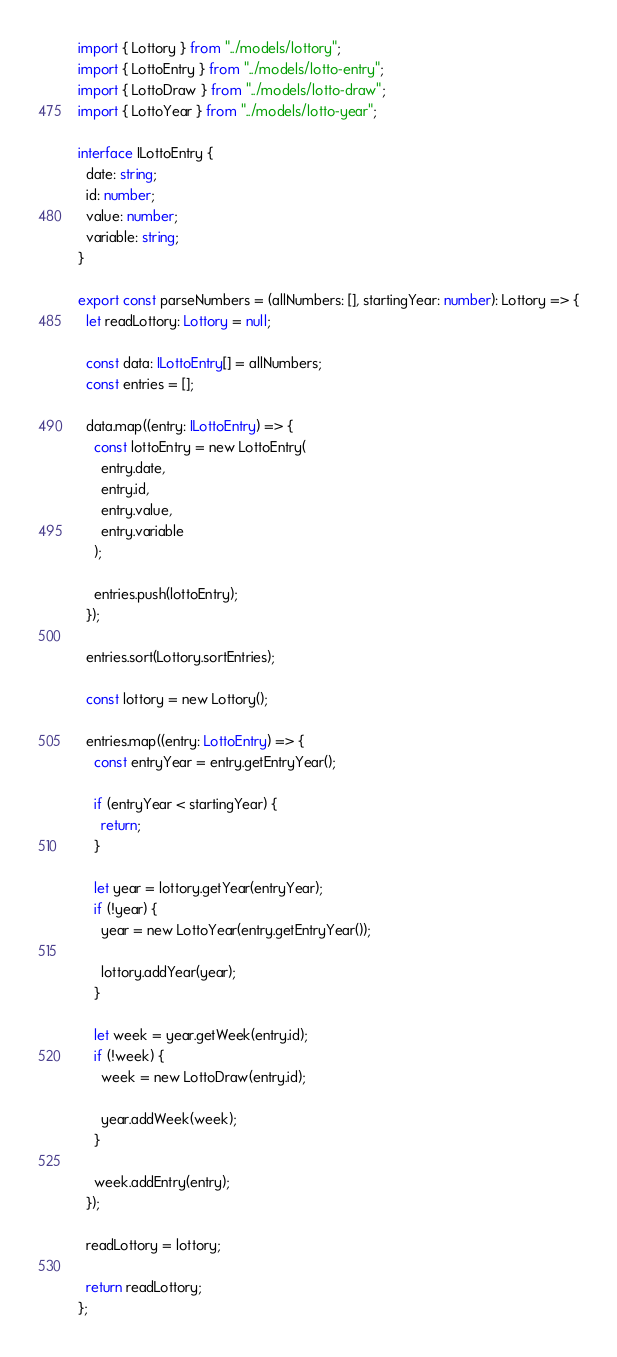Convert code to text. <code><loc_0><loc_0><loc_500><loc_500><_TypeScript_>import { Lottory } from "../models/lottory";
import { LottoEntry } from "../models/lotto-entry";
import { LottoDraw } from "../models/lotto-draw";
import { LottoYear } from "../models/lotto-year";

interface ILottoEntry {
  date: string;
  id: number;
  value: number;
  variable: string;
}

export const parseNumbers = (allNumbers: [], startingYear: number): Lottory => {
  let readLottory: Lottory = null;

  const data: ILottoEntry[] = allNumbers;
  const entries = [];

  data.map((entry: ILottoEntry) => {
    const lottoEntry = new LottoEntry(
      entry.date,
      entry.id,
      entry.value,
      entry.variable
    );

    entries.push(lottoEntry);
  });

  entries.sort(Lottory.sortEntries);

  const lottory = new Lottory();

  entries.map((entry: LottoEntry) => {
    const entryYear = entry.getEntryYear();

    if (entryYear < startingYear) {
      return;
    }

    let year = lottory.getYear(entryYear);
    if (!year) {
      year = new LottoYear(entry.getEntryYear());

      lottory.addYear(year);
    }

    let week = year.getWeek(entry.id);
    if (!week) {
      week = new LottoDraw(entry.id);

      year.addWeek(week);
    }

    week.addEntry(entry);
  });

  readLottory = lottory;

  return readLottory;
};
</code> 